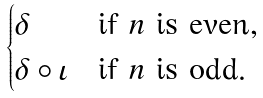<formula> <loc_0><loc_0><loc_500><loc_500>\begin{cases} \delta & \text {if $n$ is even} , \\ \delta \circ \iota & \text {if $n$ is odd} . \end{cases}</formula> 